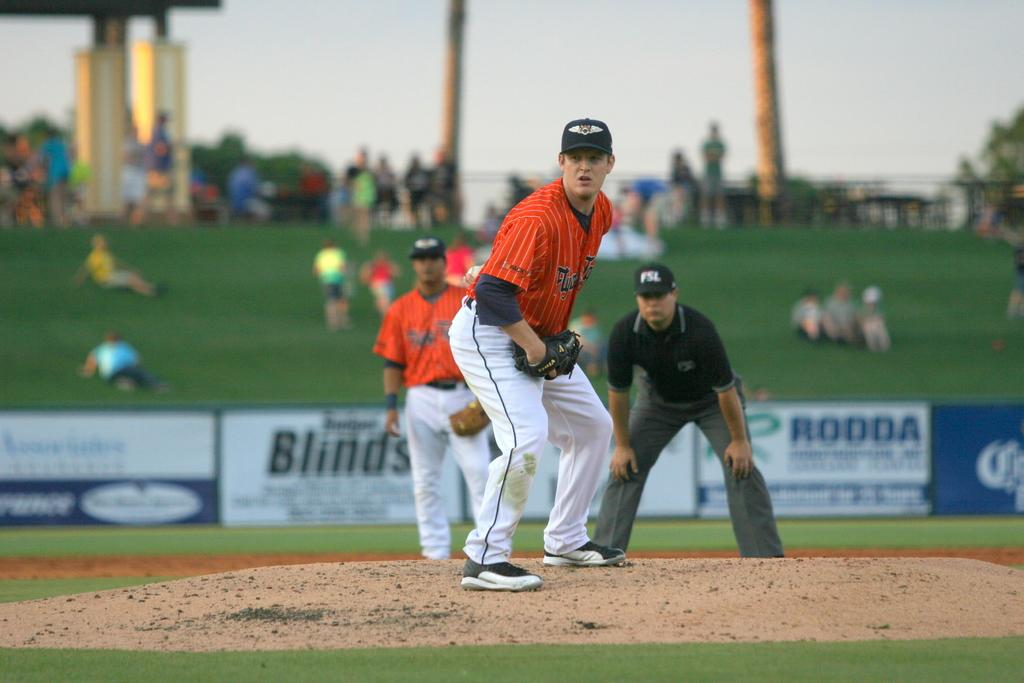What is the person in the foreground holding in the image? The person in the foreground is holding a ball. Can you describe the clothing or accessories the person is wearing? The person is wearing a cap and gloves. How many other people are visible in the image? There are two other people visible in the image. What are the two people at the back doing? The two people at the back are playing baseball. What type of flowers can be seen growing near the baseball players in the image? There are no flowers visible in the image; it features people playing baseball. What is the temper of the person in the foreground while holding the ball? The image does not provide information about the person's temper; it only shows them holding a ball and wearing a cap and gloves. 